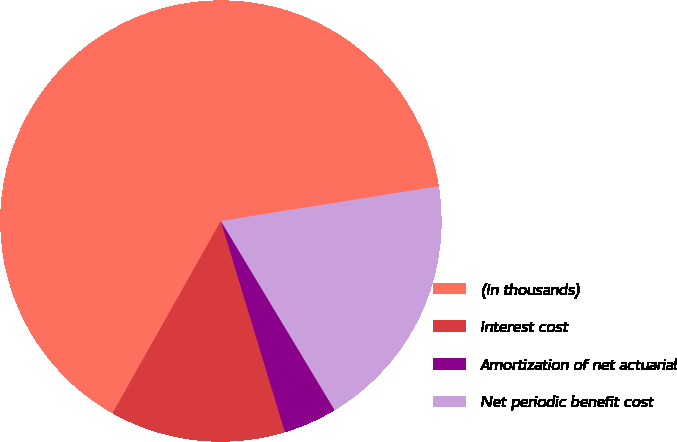Convert chart. <chart><loc_0><loc_0><loc_500><loc_500><pie_chart><fcel>(In thousands)<fcel>Interest cost<fcel>Amortization of net actuarial<fcel>Net periodic benefit cost<nl><fcel>64.31%<fcel>12.86%<fcel>3.93%<fcel>18.9%<nl></chart> 